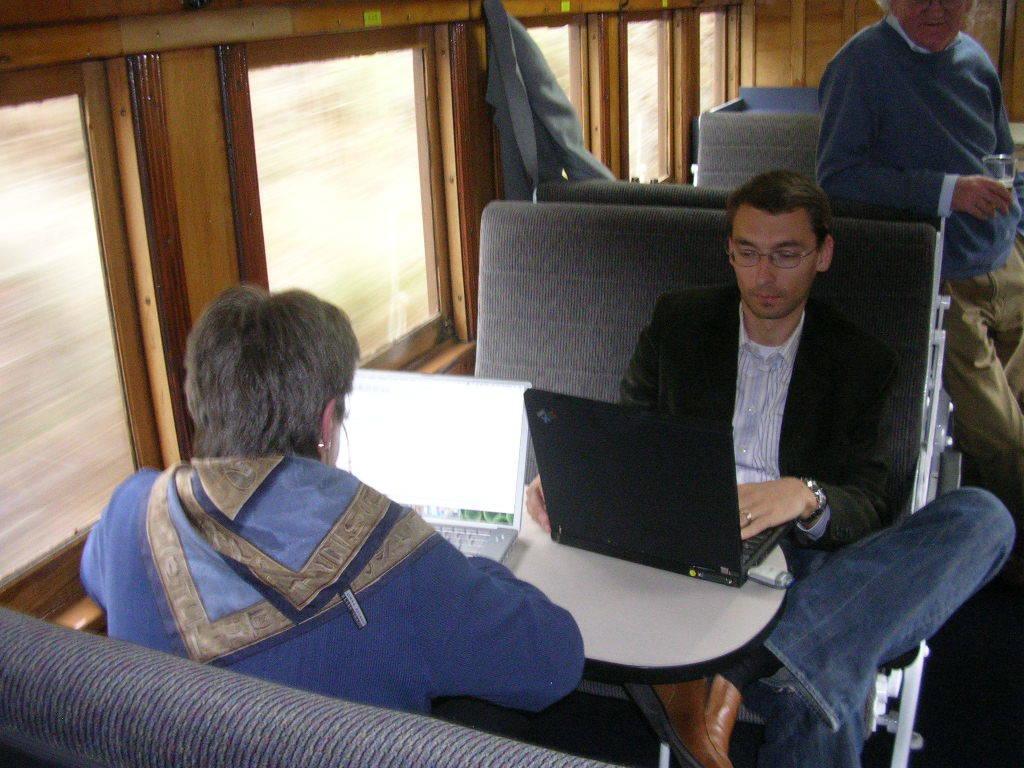Describe this image in one or two sentences. In this image I can see three people among them two people are sitting and operating laptops. Here I can see windows and other objects. 